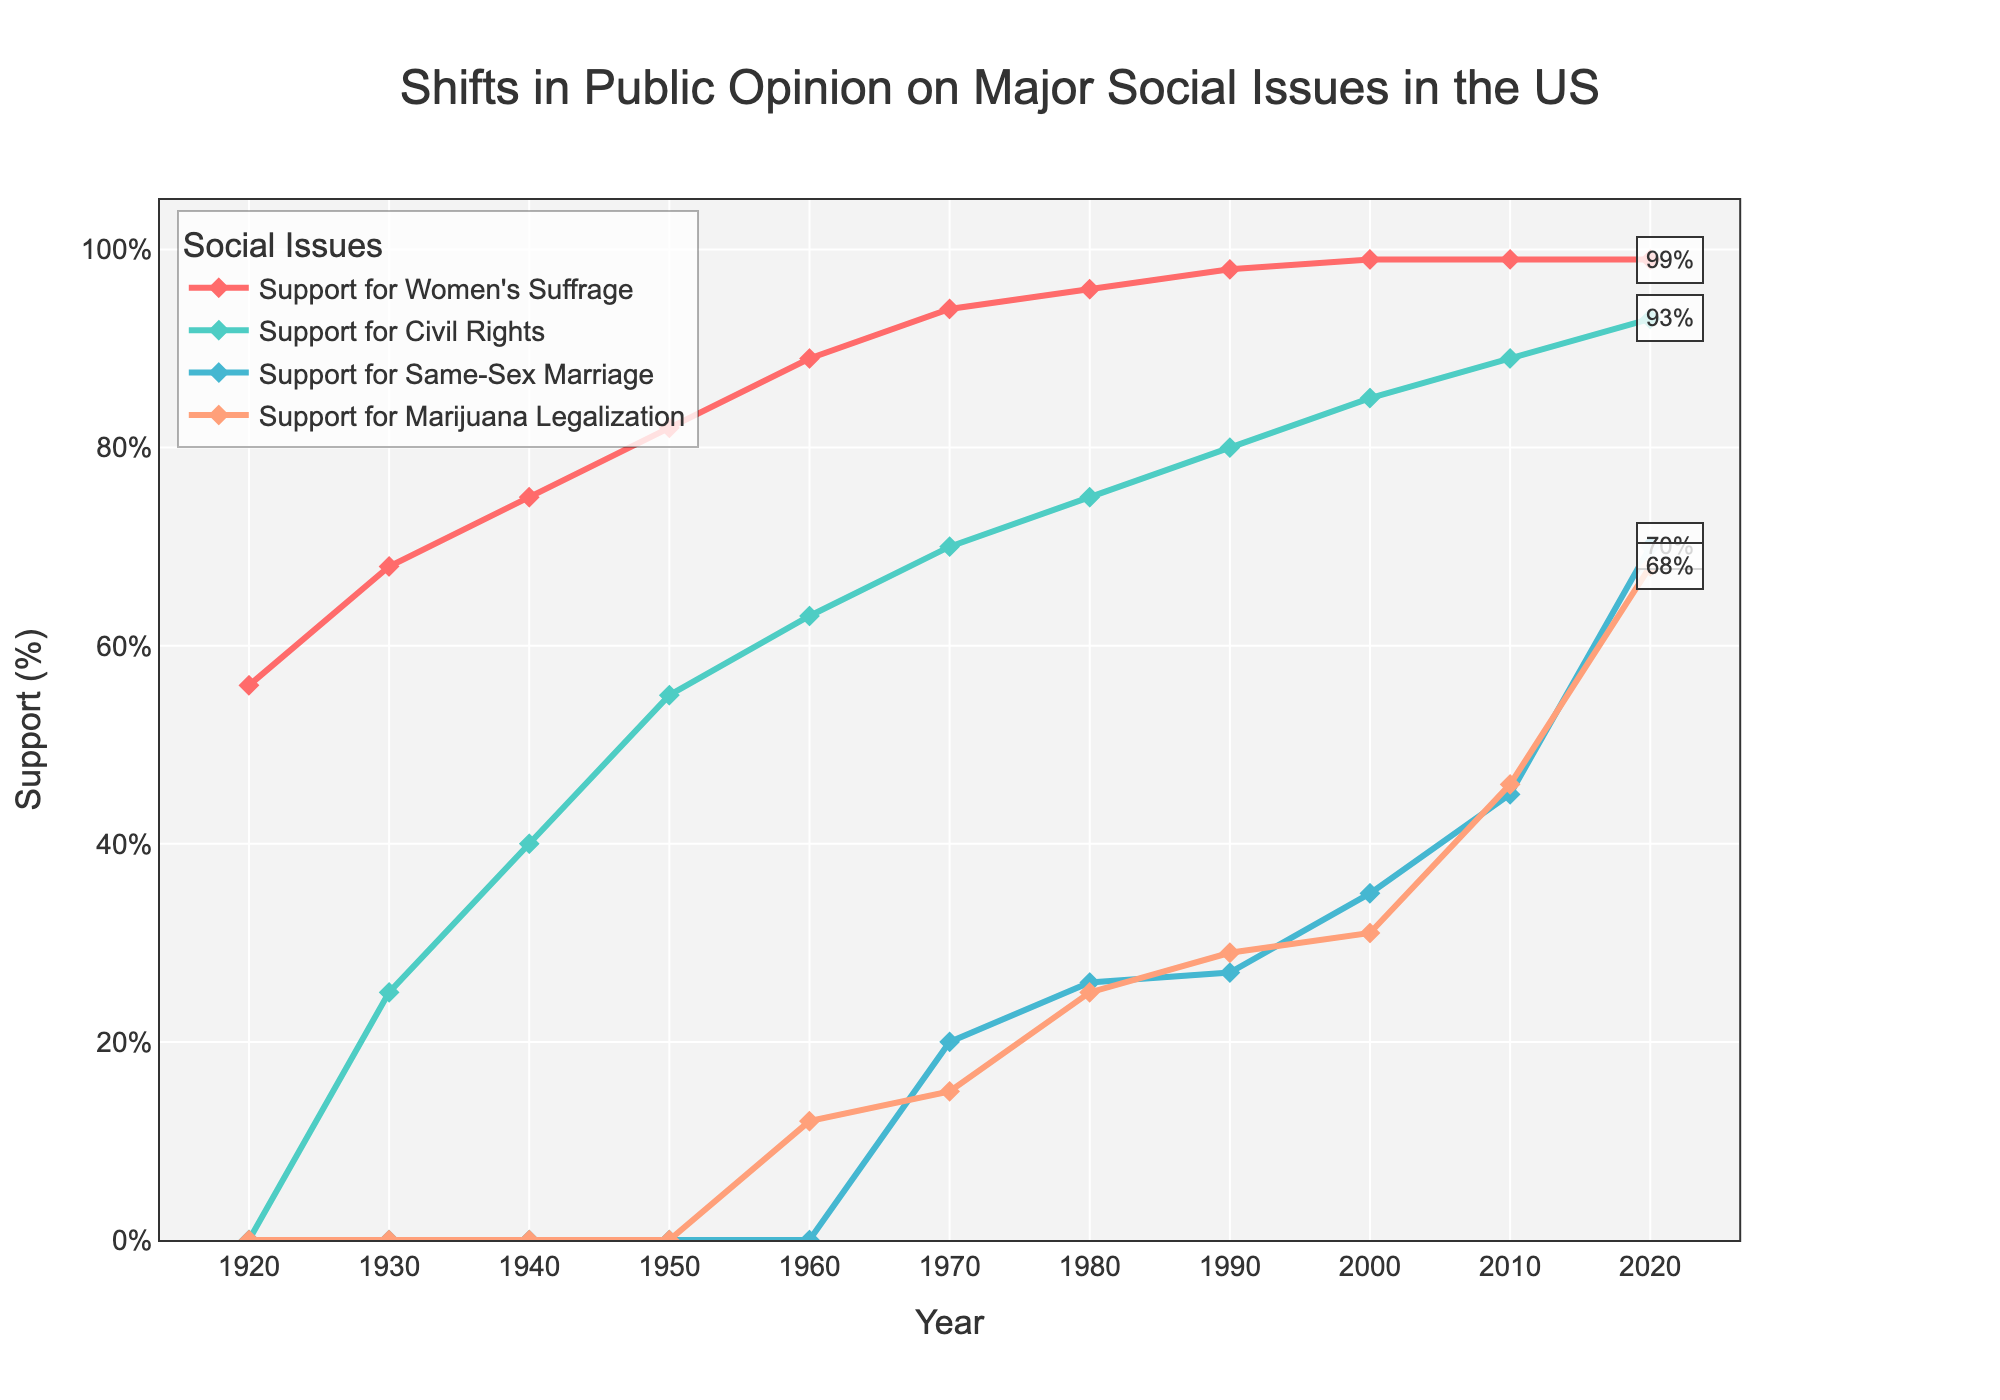What year did public support for civil rights first surpass 50%? Look for the year in which the line representing support for civil rights first crosses the 50% mark on the y-axis. According to the figure, this happens in 1950.
Answer: 1950 Which social issue has consistently had the highest support throughout the data range? Examine the lines on the graph for each social issue. The line for support for women's suffrage remains the highest consistently from 1920 to 2020.
Answer: Women's suffrage Between which two decades did support for same-sex marriage see the largest increase? Observe the increments between consecutive decades for the support for same-sex marriage line. The largest increase is between 2010 (45%) and 2020 (70%), an increase of 25%.
Answer: 2010 to 2020 What was the percentage difference between support for marijuana legalization and support for same-sex marriage in 2000? Compare the support percentages for both issues in the year 2000. Marijuana legalization had 31% support, while same-sex marriage had 35% support. The difference is 35% - 31% = 4%.
Answer: 4% In what year did support for marijuana legalization first exceed 50%? Look at the line representing support for marijuana legalization and identify the first year it crosses the 50% mark. This happens in 2010.
Answer: 2010 Compare the growth in support for civil rights from 1940 to 1960 with the growth in support for same-sex marriage from 1980 to 2000. Which one had a higher increase? Calculate the increase for each period: Civil rights support grew from 40% to 63% (a 23% increase) between 1940 and 1960. Same-sex marriage support grew from 26% to 35% (a 9% increase) between 1980 and 2000.
Answer: Civil rights What is the average support percentage for women's suffrage across all recorded years? Sum up all the support percentages for women’s suffrage across all recorded years and divide by the number of data points (11 years): (56 + 68 + 75 + 82 + 89 + 94 + 96 + 98 + 99 + 99 + 99) / 11 = 97.
Answer: 87% How does support for civil rights in 2020 compare to support for marijuana legalization in the same year? Identify the support percentages for both issues in 2020. Civil rights have 93% support, while marijuana legalization has 68%. Comparing the two, civil rights support is higher.
Answer: Civil rights is higher Which social issue showed zero support in the earliest recorded year (1920)? Look at the data points for the year 1920. Both same-sex marriage and marijuana legalization show 0% support in that year.
Answer: Same-sex marriage and marijuana legalization By what percentage did support for women's suffrage increase from 1920 to 1940? Subtract the support percentage in 1920 from that in 1940. The increase is 75% - 56% = 19%.
Answer: 19% 